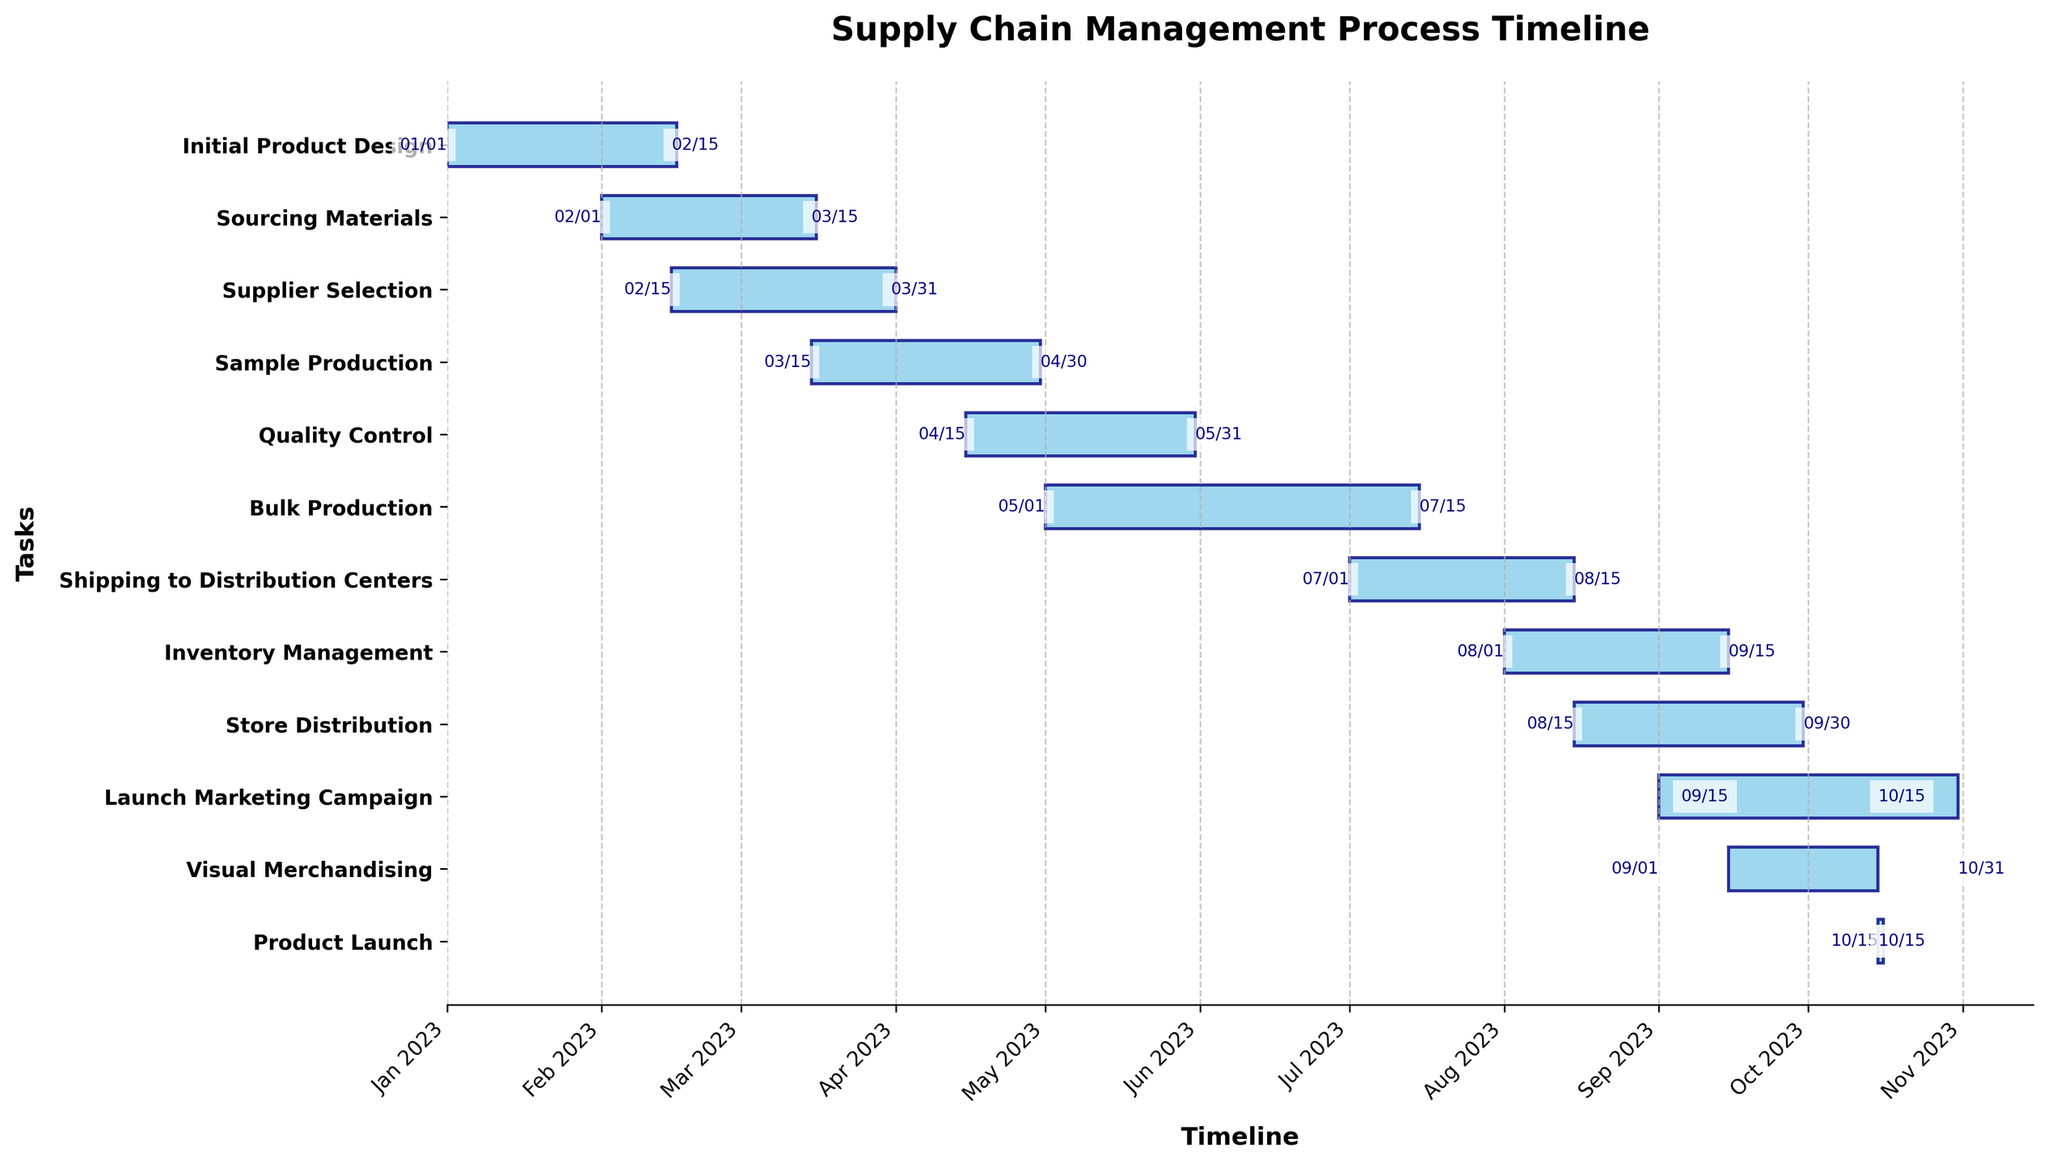What's the title of this chart? The title of the chart is displayed at the top center of the figure. It reads "Supply Chain Management Process Timeline".
Answer: Supply Chain Management Process Timeline Which task starts the earliest? The tasks are represented by horizontal bars on the chart, and the task that has the earliest starting date is "Initial Product Design," which starts on 2023-01-01.
Answer: Initial Product Design What is the duration of the "Quality Control" task? Each task on the chart has its duration shown in days next to it. The duration for "Quality Control" is indicated to be 46 days.
Answer: 46 days How many tasks are concurrently ongoing in March 2023? Find the tasks that overlap in the month of March 2023 by looking at their start and end dates. "Sourcing Materials," "Supplier Selection," and "Sample Production" occur in March. Therefore, three tasks are ongoing concurrently in March.
Answer: 3 Which two tasks have overlapping timelines in April 2023? Scan the chart for tasks that share the same timeline in April. You will find that "Sample Production" and "Quality Control" both have activities during April 2023.
Answer: Sample Production and Quality Control When does the "Bulk Production" task end? Look for the task "Bulk Production" on the chart and check its end date, which is labeled as 2023-07-15.
Answer: 2023-07-15 Which task has the shortest duration and what is its duration? The chart shows the duration of each task. The "Product Launch" task has the shortest duration of 1 day.
Answer: Product Launch, 1 day Which task starts immediately after "Bulk Production"? By looking at the end date of "Bulk Production" and then identifying the next task start date, we see that "Shipping to Distribution Centers" follows, starting on 2023-07-01.
Answer: Shipping to Distribution Centers How long does the "Launch Marketing Campaign" task run before the "Product Launch"? "Launch Marketing Campaign" starts on 2023-09-01 and "Product Launch" occurs on 2023-10-15. Calculate the difference between these dates. "Launch Marketing Campaign" runs for 45 days before the "Product Launch."
Answer: 45 days Which phases of the supply chain overlap with the "Store Distribution" phase? Identify phases between the start (2023-08-15) and end (2023-09-30) of "Store Distribution." It overlaps with "Inventory Management," "Visual Merchandising," and "Launch Marketing Campaign."
Answer: Inventory Management, Visual Merchandising, Launch Marketing Campaign 